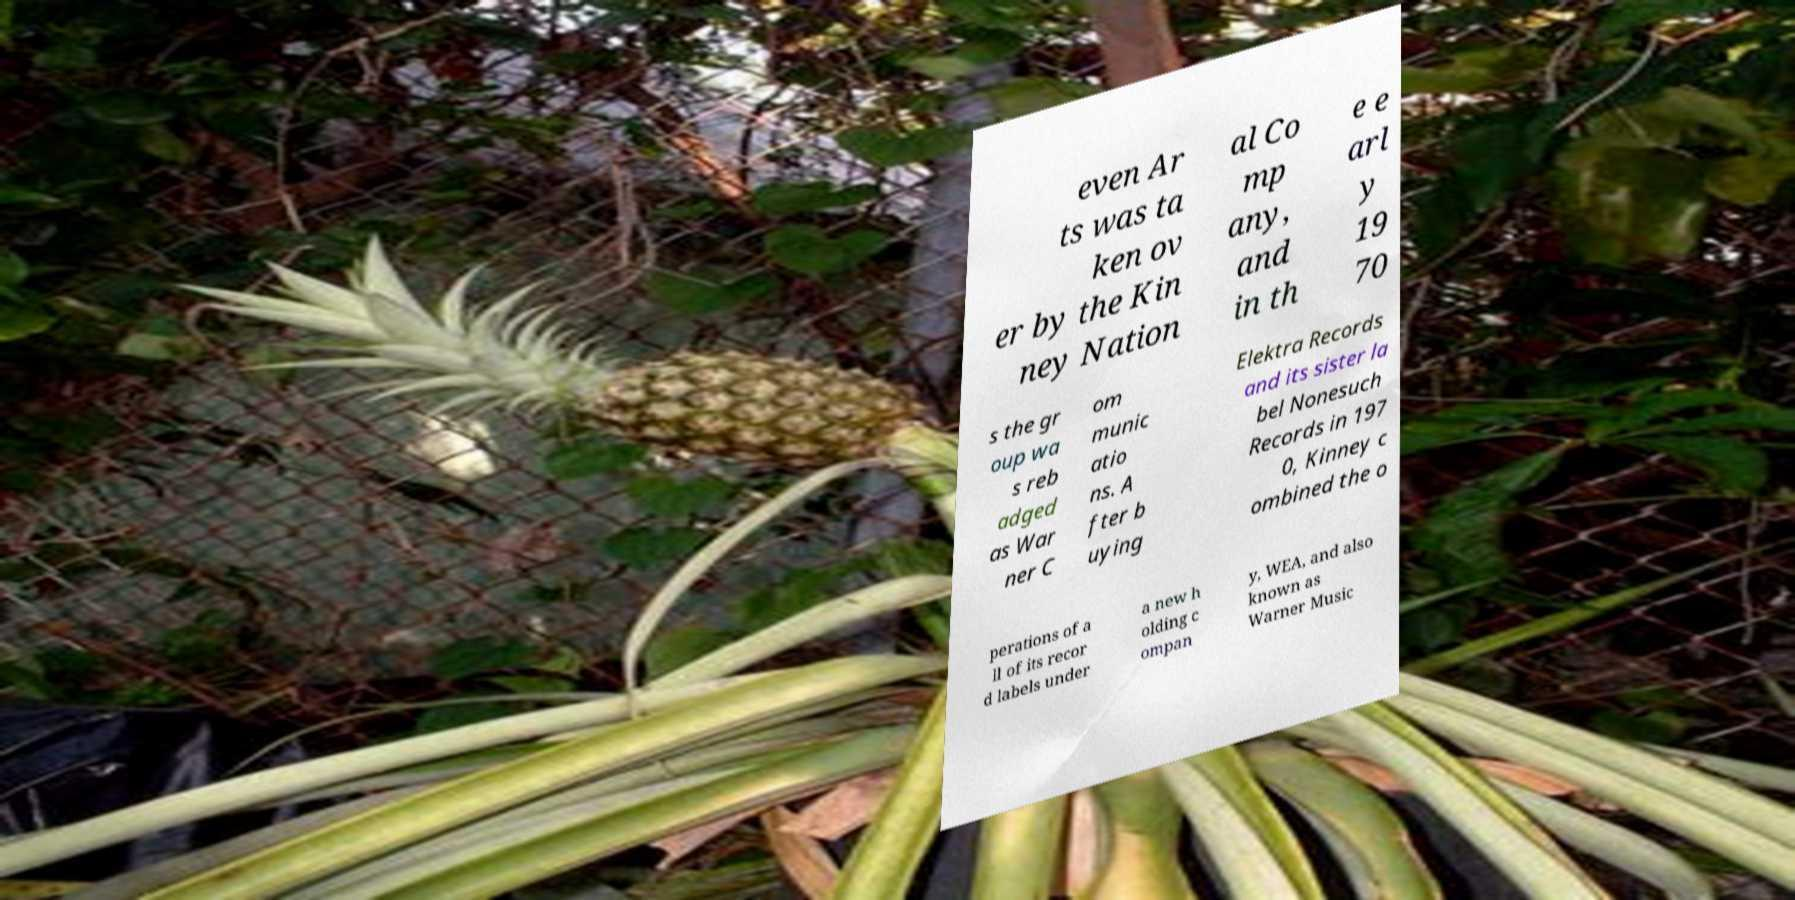Can you read and provide the text displayed in the image?This photo seems to have some interesting text. Can you extract and type it out for me? even Ar ts was ta ken ov er by the Kin ney Nation al Co mp any, and in th e e arl y 19 70 s the gr oup wa s reb adged as War ner C om munic atio ns. A fter b uying Elektra Records and its sister la bel Nonesuch Records in 197 0, Kinney c ombined the o perations of a ll of its recor d labels under a new h olding c ompan y, WEA, and also known as Warner Music 